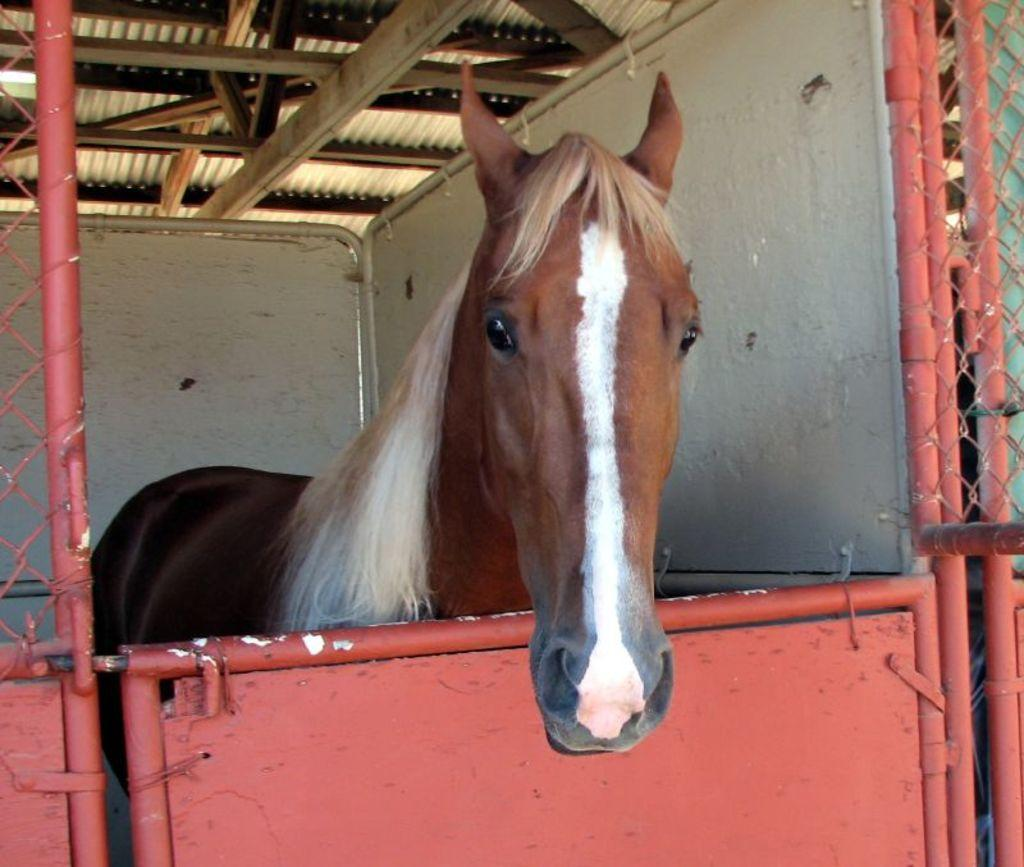What type of animal is in a cage in the image? There is a horse in a cage in the image. What part of a building can be seen at the top of the image? There is a roof visible at the top of the image. How many toes does the horse have in the image? The number of toes the horse has cannot be determined from the image alone. What type of amphibian can be seen on the page in the image? There is no page or amphibian, such as a frog, present in the image. 